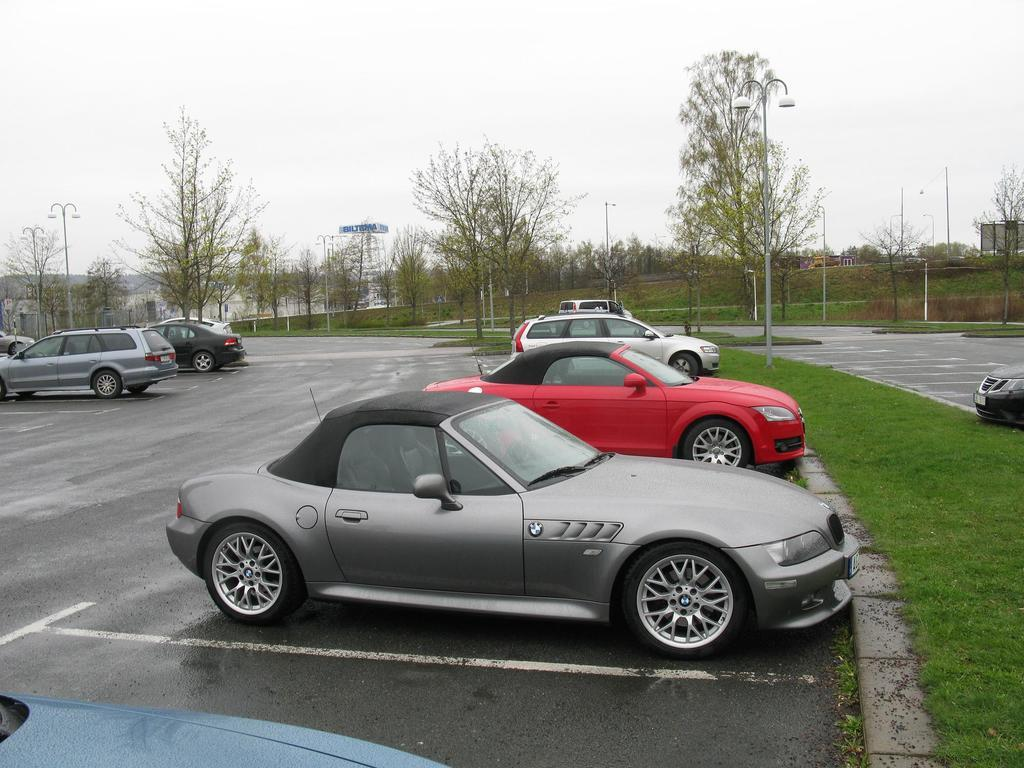What types of vehicles can be seen in the image? There are many vehicles of different colors and sizes in the image. What is the primary surface visible in the image? There is a road visible in the image. What type of natural environment is present in the image? There is grass and trees in the image. What man-made structures can be seen in the image? There are poles in the image. What is the color of the sky in the image? The sky is white in the image. What type of sofa can be seen in the image? There is no sofa present in the image. What shape is the dust visible in the image? There is no dust visible in the image. 